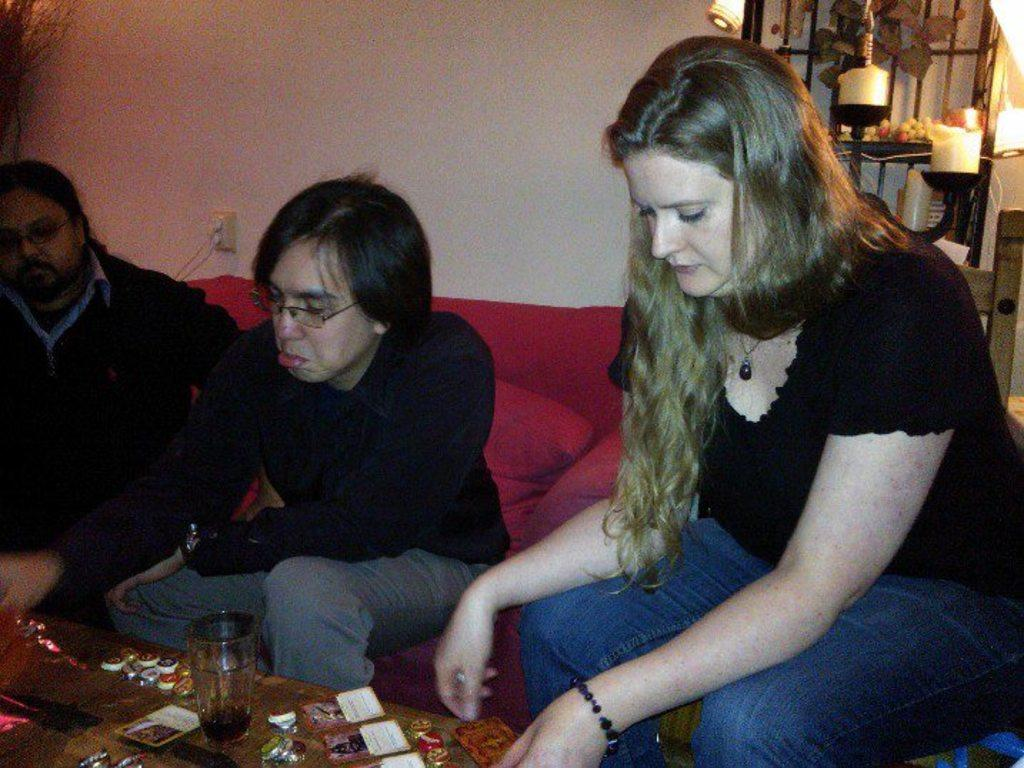How many people are sitting in the image? There are three persons sitting in the image. What is on the table in front of the people? There is a glass on the table, and there are some objects on the table as well. What type of furniture is present in the image? There is a sofa and a chair in the image. What can be seen in the background of the image? There is a wall in the background, and there are lights and some objects on a table in the background. What type of canvas is the woman painting in the image? There is no woman or canvas present in the image. What story is being told by the people sitting in the image? The image does not depict a story being told; it simply shows three people sitting. 